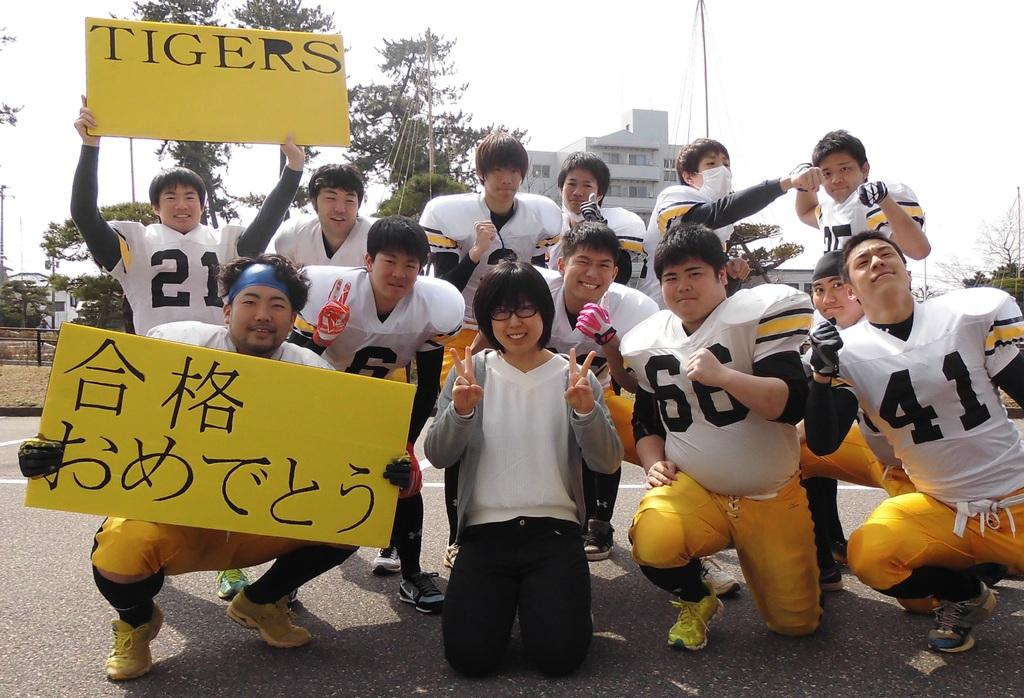What type of people are in the image? There are Chinese players in the image. What are the players doing in the image? The players are posing for a picture. What objects are some of the players holding? Some players are holding boards. What is written on the boards? The boards have "TIGERS" written on them. What type of science experiment is being conducted in the image? There is no science experiment present in the image; it features Chinese players posing for a picture with boards that have "TIGERS" written on them. What color is the shirt worn by the player in the center of the image? There is no shirt color mentioned in the provided facts, as the focus is on the players, their actions, and the boards they are holding. 